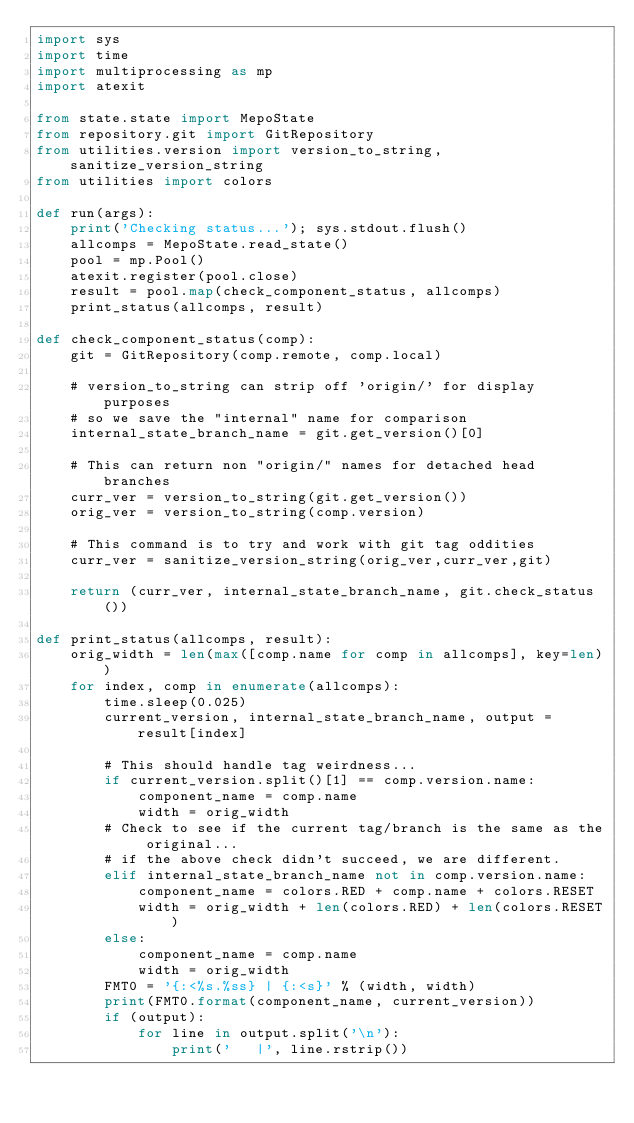Convert code to text. <code><loc_0><loc_0><loc_500><loc_500><_Python_>import sys
import time
import multiprocessing as mp
import atexit

from state.state import MepoState
from repository.git import GitRepository
from utilities.version import version_to_string, sanitize_version_string
from utilities import colors

def run(args):
    print('Checking status...'); sys.stdout.flush()
    allcomps = MepoState.read_state()
    pool = mp.Pool()
    atexit.register(pool.close)
    result = pool.map(check_component_status, allcomps)
    print_status(allcomps, result)

def check_component_status(comp):
    git = GitRepository(comp.remote, comp.local)

    # version_to_string can strip off 'origin/' for display purposes
    # so we save the "internal" name for comparison
    internal_state_branch_name = git.get_version()[0]

    # This can return non "origin/" names for detached head branches
    curr_ver = version_to_string(git.get_version())
    orig_ver = version_to_string(comp.version)

    # This command is to try and work with git tag oddities
    curr_ver = sanitize_version_string(orig_ver,curr_ver,git)

    return (curr_ver, internal_state_branch_name, git.check_status())

def print_status(allcomps, result):
    orig_width = len(max([comp.name for comp in allcomps], key=len))
    for index, comp in enumerate(allcomps):
        time.sleep(0.025)
        current_version, internal_state_branch_name, output = result[index]

        # This should handle tag weirdness...
        if current_version.split()[1] == comp.version.name:
            component_name = comp.name
            width = orig_width
        # Check to see if the current tag/branch is the same as the original...
        # if the above check didn't succeed, we are different.
        elif internal_state_branch_name not in comp.version.name:
            component_name = colors.RED + comp.name + colors.RESET
            width = orig_width + len(colors.RED) + len(colors.RESET)
        else:
            component_name = comp.name
            width = orig_width
        FMT0 = '{:<%s.%ss} | {:<s}' % (width, width)
        print(FMT0.format(component_name, current_version))
        if (output):
            for line in output.split('\n'):
                print('   |', line.rstrip())
</code> 